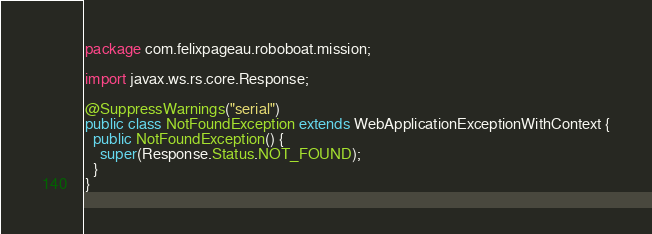<code> <loc_0><loc_0><loc_500><loc_500><_Java_>package com.felixpageau.roboboat.mission;

import javax.ws.rs.core.Response;

@SuppressWarnings("serial")
public class NotFoundException extends WebApplicationExceptionWithContext {
  public NotFoundException() {
    super(Response.Status.NOT_FOUND);
  }
}</code> 